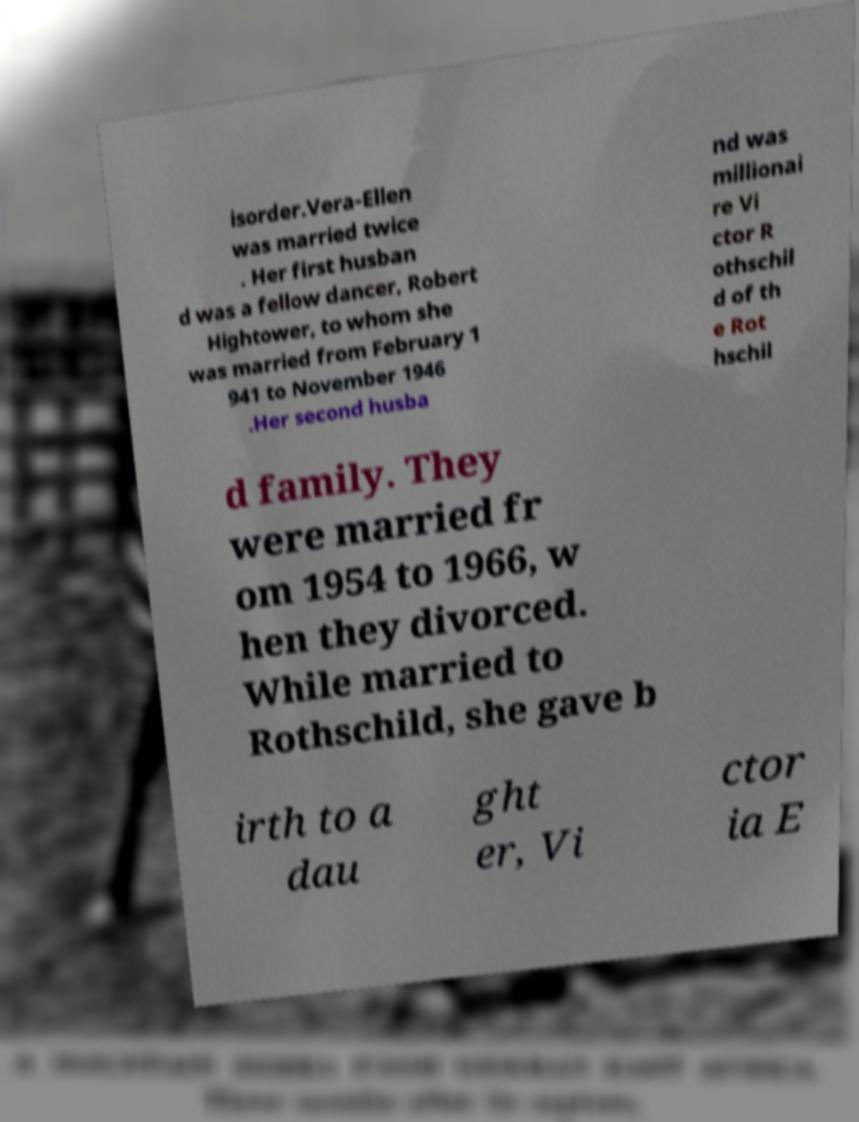Could you assist in decoding the text presented in this image and type it out clearly? isorder.Vera-Ellen was married twice . Her first husban d was a fellow dancer, Robert Hightower, to whom she was married from February 1 941 to November 1946 .Her second husba nd was millionai re Vi ctor R othschil d of th e Rot hschil d family. They were married fr om 1954 to 1966, w hen they divorced. While married to Rothschild, she gave b irth to a dau ght er, Vi ctor ia E 